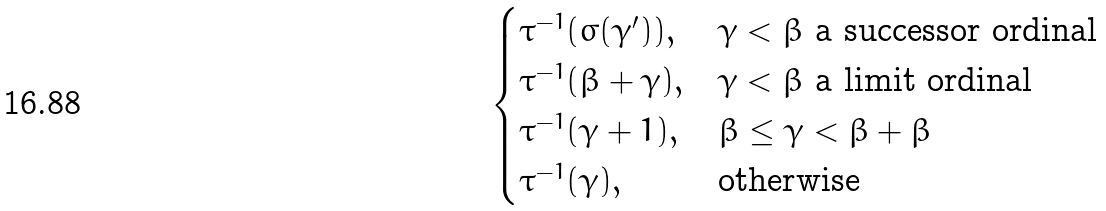<formula> <loc_0><loc_0><loc_500><loc_500>\begin{cases} \tau ^ { - 1 } ( \sigma ( \gamma ^ { \prime } ) ) , & \gamma < \beta \text { a successor ordinal} \\ \tau ^ { - 1 } ( \beta + \gamma ) , & \gamma < \beta \text { a limit ordinal} \\ \tau ^ { - 1 } ( \gamma + 1 ) , & \beta \leq \gamma < \beta + \beta \\ \tau ^ { - 1 } ( \gamma ) , & \text {otherwise} \\ \end{cases}</formula> 